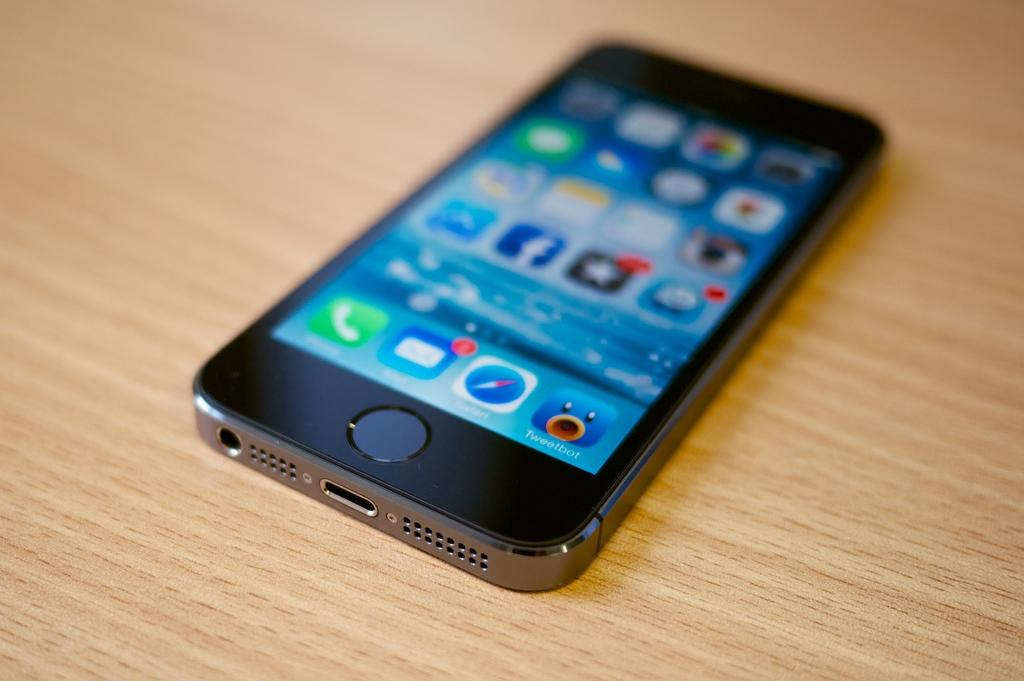<image>
Provide a brief description of the given image. Cellphone with an app called Tweetbot towards the bottom. 